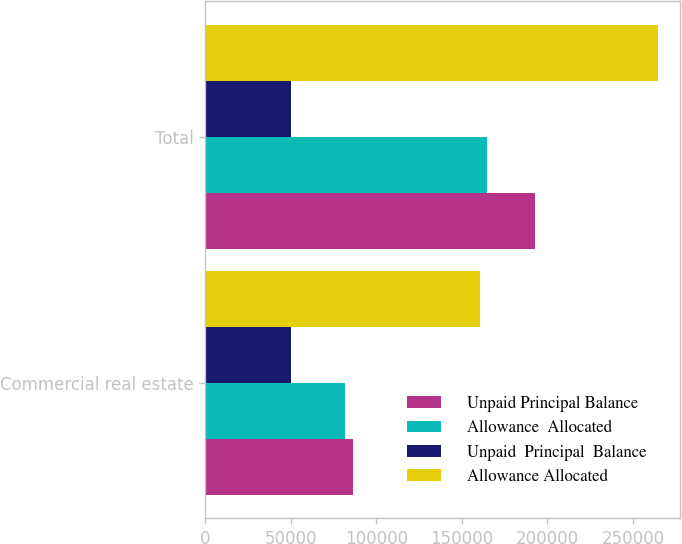Convert chart. <chart><loc_0><loc_0><loc_500><loc_500><stacked_bar_chart><ecel><fcel>Commercial real estate<fcel>Total<nl><fcel>Unpaid Principal Balance<fcel>86121<fcel>192744<nl><fcel>Allowance  Allocated<fcel>81475<fcel>164853<nl><fcel>Unpaid  Principal  Balance<fcel>50175<fcel>50175<nl><fcel>Allowance Allocated<fcel>160711<fcel>264389<nl></chart> 